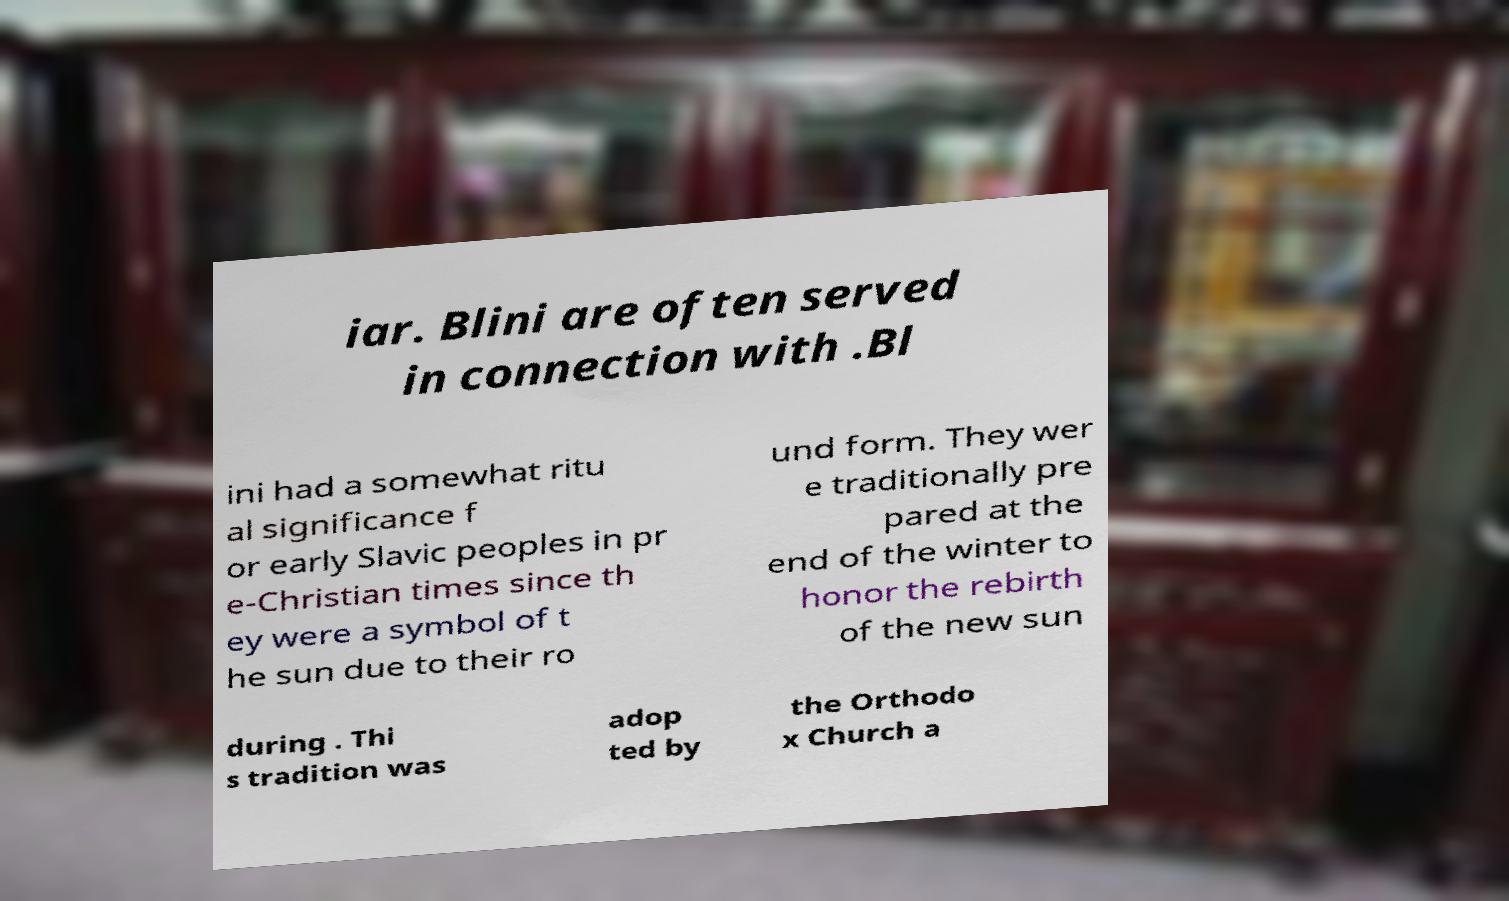What messages or text are displayed in this image? I need them in a readable, typed format. iar. Blini are often served in connection with .Bl ini had a somewhat ritu al significance f or early Slavic peoples in pr e-Christian times since th ey were a symbol of t he sun due to their ro und form. They wer e traditionally pre pared at the end of the winter to honor the rebirth of the new sun during . Thi s tradition was adop ted by the Orthodo x Church a 